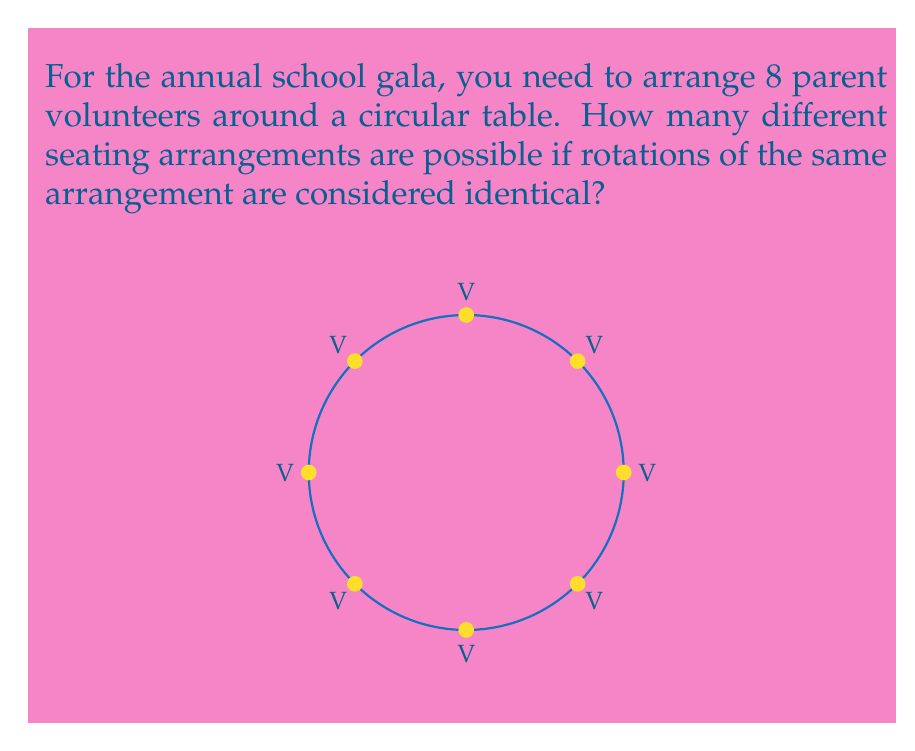What is the answer to this math problem? Let's approach this step-by-step:

1) First, we need to recognize that this is a circular permutation problem. In circular permutations, rotations of the same arrangement are considered identical.

2) For linear arrangements of n distinct objects, we would use n! (n factorial). However, for circular arrangements, we need to adjust this.

3) In a circular arrangement, we can fix the position of one volunteer and then arrange the rest. This is because rotations are considered the same arrangement.

4) So, we effectively need to arrange (n-1) volunteers, where n is the total number of volunteers.

5) In this case, we have 8 volunteers in total. So we need to calculate (8-1)! = 7!

6) 7! can be calculated as follows:
   $$7! = 7 \times 6 \times 5 \times 4 \times 3 \times 2 \times 1 = 5040$$

Therefore, there are 5040 different possible seating arrangements for the 8 parent volunteers around the circular table.
Answer: 5040 